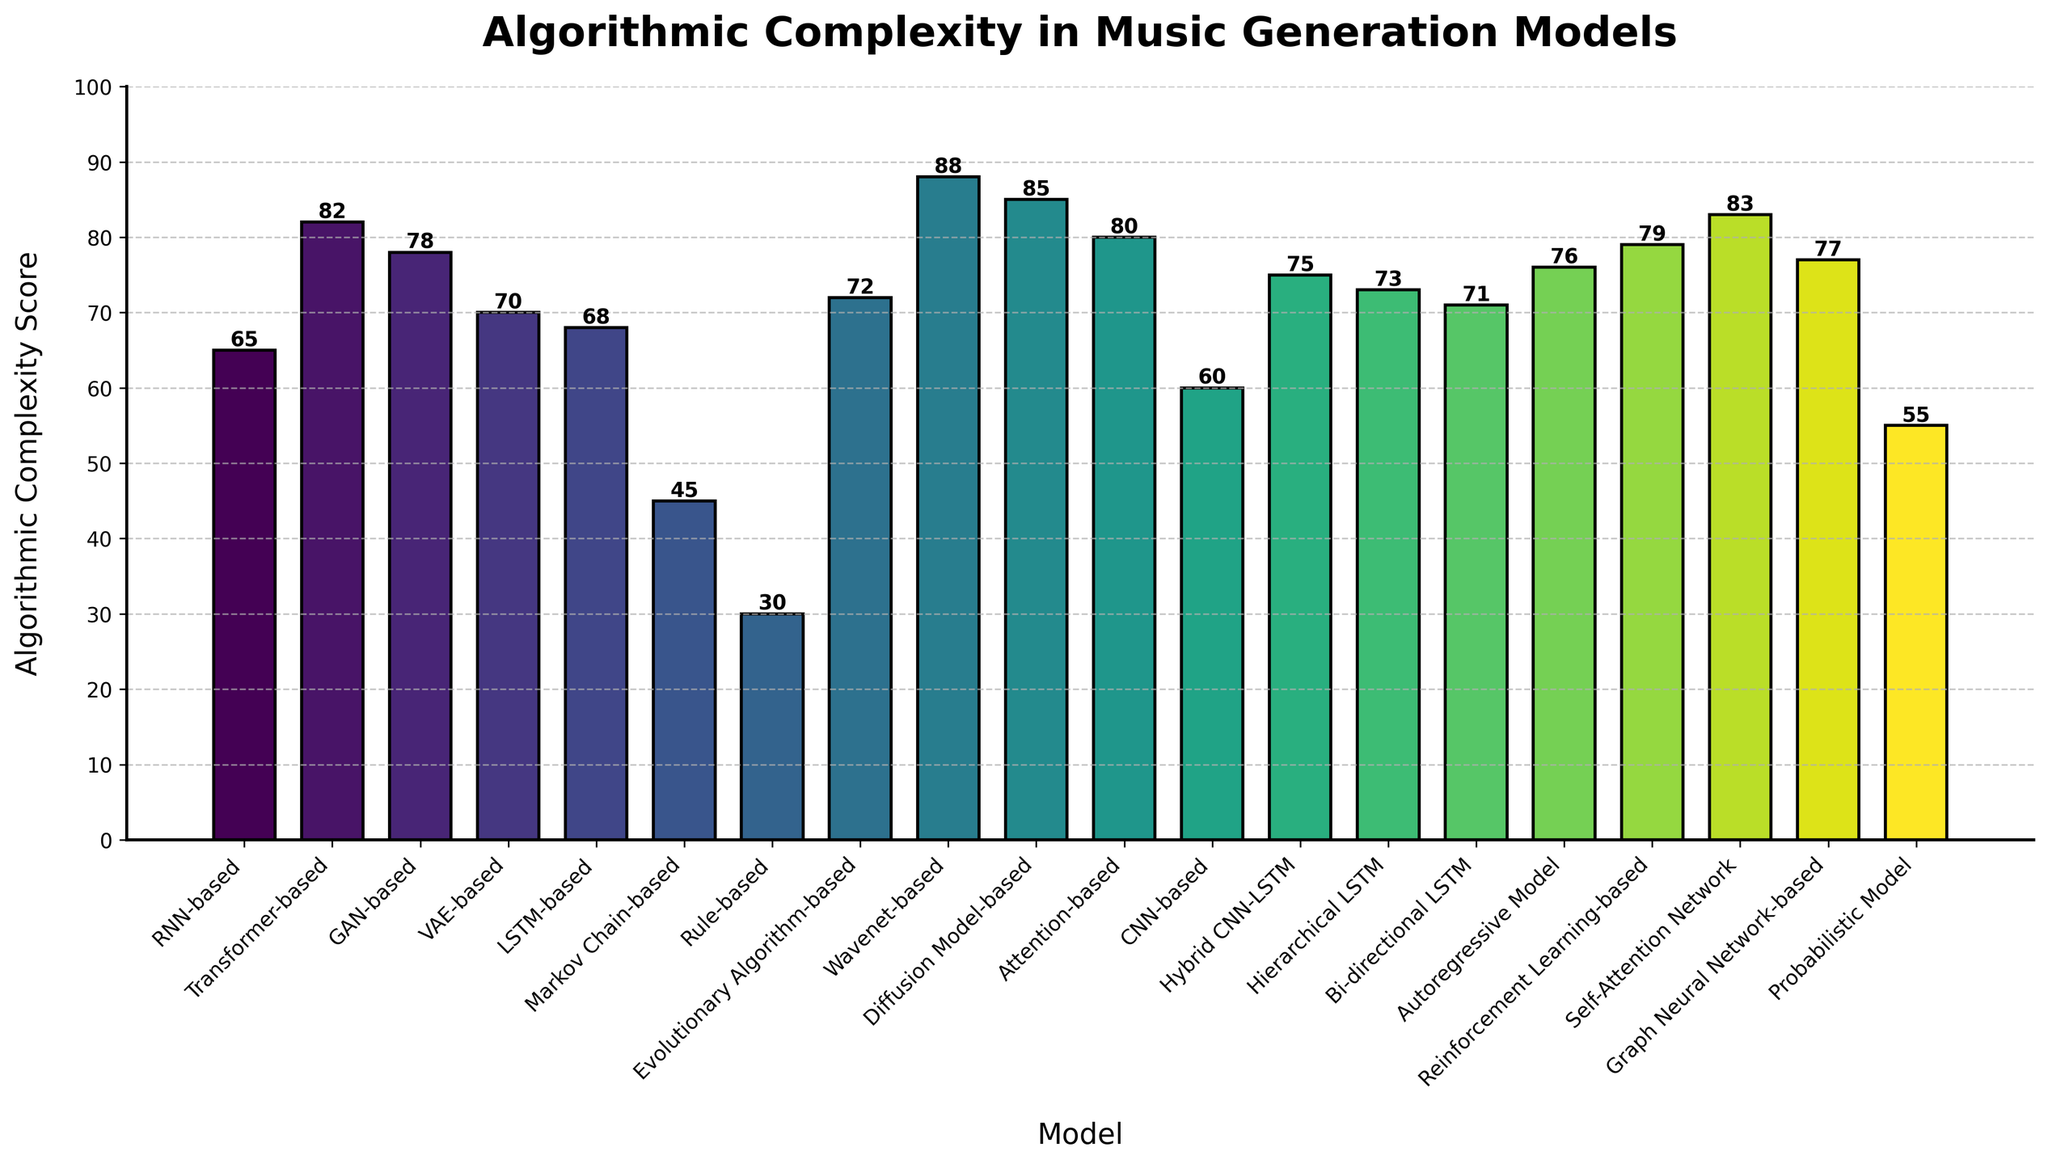Which model has the highest algorithmic complexity score? The model with the highest bar and the number at the top of the bar show the highest algorithmic complexity score. The Wavenet-based model has the tallest bar with a score of 88.
Answer: Wavenet-based Which model has the lowest algorithmic complexity score? The model with the shortest bar and the number at the top of the bar show the lowest algorithmic complexity score. The Rule-based model has the shortest bar with a score of 30.
Answer: Rule-based What is the difference in algorithmic complexity score between the Transformer-based and RNN-based models? The height of the bars for the Transformer-based and RNN-based models indicate their scores are 82 and 65 respectively. Subtracting the RNN-based score from the Transformer-based score (82 - 65) gives the difference.
Answer: 17 What is the average algorithmic complexity score of the LSTM-based models (LSTM-based, Hierarchical LSTM, Bi-directional LSTM, Hybrid CNN-LSTM)? The scores for the LSTM-based models are added (68 + 73 + 71 + 75) = 287. Dividing by the number of models (4) gives the average score.
Answer: 71.75 Which model has a higher algorithmic complexity score, the GAN-based or the Diffusion Model-based? Comparing the height of the bars for the GAN-based and Diffusion Model-based models shows the scores are 78 and 85 respectively. 85 is higher than 78.
Answer: Diffusion Model-based What is the total algorithmic complexity score of the models with scores above 80? The models with scores above 80 are Transformer-based (82), Diffusion Model-based (85), Self-Attention Network (83), and Wavenet-based (88). Summing these scores (82 + 85 + 83 + 88) gives the total.
Answer: 338 How many models have an algorithmic complexity score greater than 75? Counting the bars with heights indicating scores greater than 75, the models are Transformer-based, Diffusion Model-based, Self-Attention Network, Wavenet-based, Reinforcement Learning-based, Autoregressive Model, and GAN-based.
Answer: 7 Between the CNN-based model and the Probabilistic Model, which one has a higher score, and what is the difference? The heights of the bars for the CNN-based and Probabilistic Models show the scores are 60 and 55 respectively. The CNN-based model has a higher score, with a difference of (60 - 55).
Answer: CNN-based, 5 What is the median algorithmic complexity score of all models shown? Listing the scores in ascending order: 30, 45, 55, 60, 65, 68, 70, 71, 72, 73, 75, 76, 77, 78, 79, 80, 82, 83, 85, 88. The median value is the middle number in the ordered list. Since there are 20 scores, the median is the average of the 10th and 11th scores ((72 + 73)/2).
Answer: 72.5 